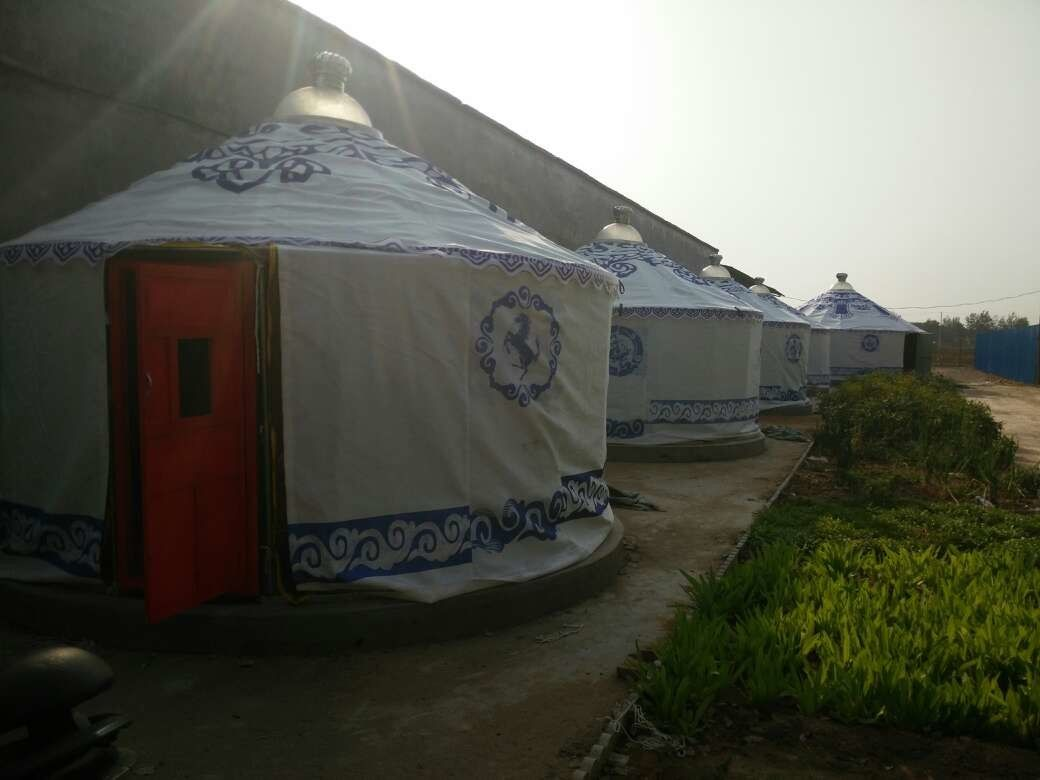What kind of activities might attendees participate in at this event? Based on the setting, attendees might engage in various cultural and educational activities. These could include traditional music and dance performances, workshops on yurt construction, storytelling sessions, and cooking classes featuring regional cuisine. Additionally, there might be discussions and presentations about nomadic lifestyles, environmental sustainability, and the history of the region. Outdoor activities such as guided nature walks, star gazing, and community games or sports could also be part of the event, making it a well-rounded experience for all age groups. How are the yurts beneficial in this context compared to modern tents or cabins? Yurts are particularly beneficial in this context due to their historical and cultural significance. They offer an immersive experience, allowing attendees to connect with the traditions being showcased. Structurally, yurts are robust and can withstand various weather conditions, while also being relatively easy to assemble and disassemble, which makes them ideal for temporary events. Unlike modern tents, yurts have better insulation and ventilation, providing a more comfortable stay. The aesthetic appeal of the yurts, with their unique designs and decorations, enhances the atmosphere and authenticity of the event, making it more memorable for attendees. 